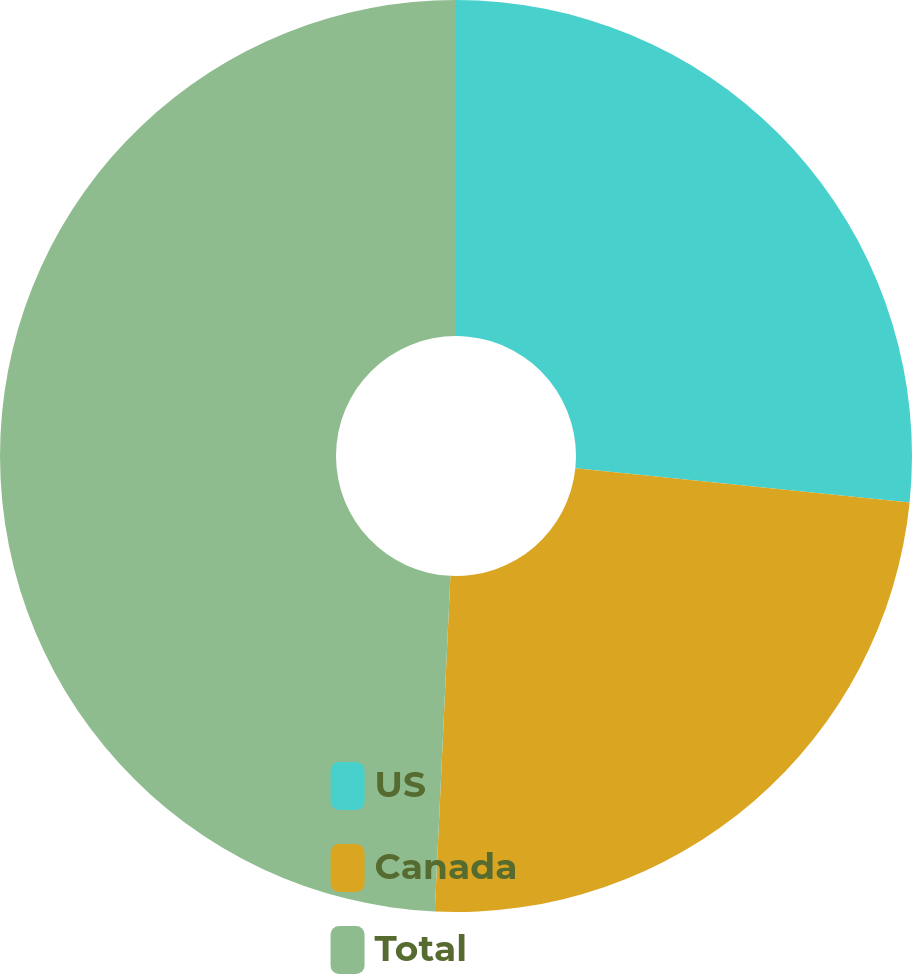<chart> <loc_0><loc_0><loc_500><loc_500><pie_chart><fcel>US<fcel>Canada<fcel>Total<nl><fcel>26.63%<fcel>24.11%<fcel>49.26%<nl></chart> 